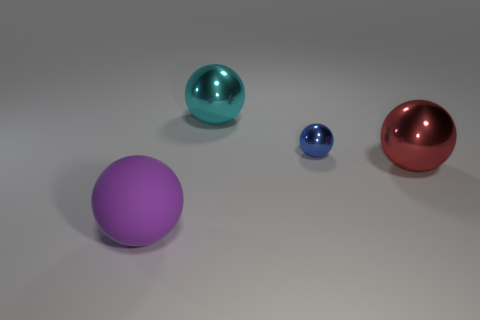Add 4 spheres. How many objects exist? 8 Subtract all brown matte spheres. Subtract all red metal objects. How many objects are left? 3 Add 2 big red spheres. How many big red spheres are left? 3 Add 4 green cubes. How many green cubes exist? 4 Subtract 0 green balls. How many objects are left? 4 